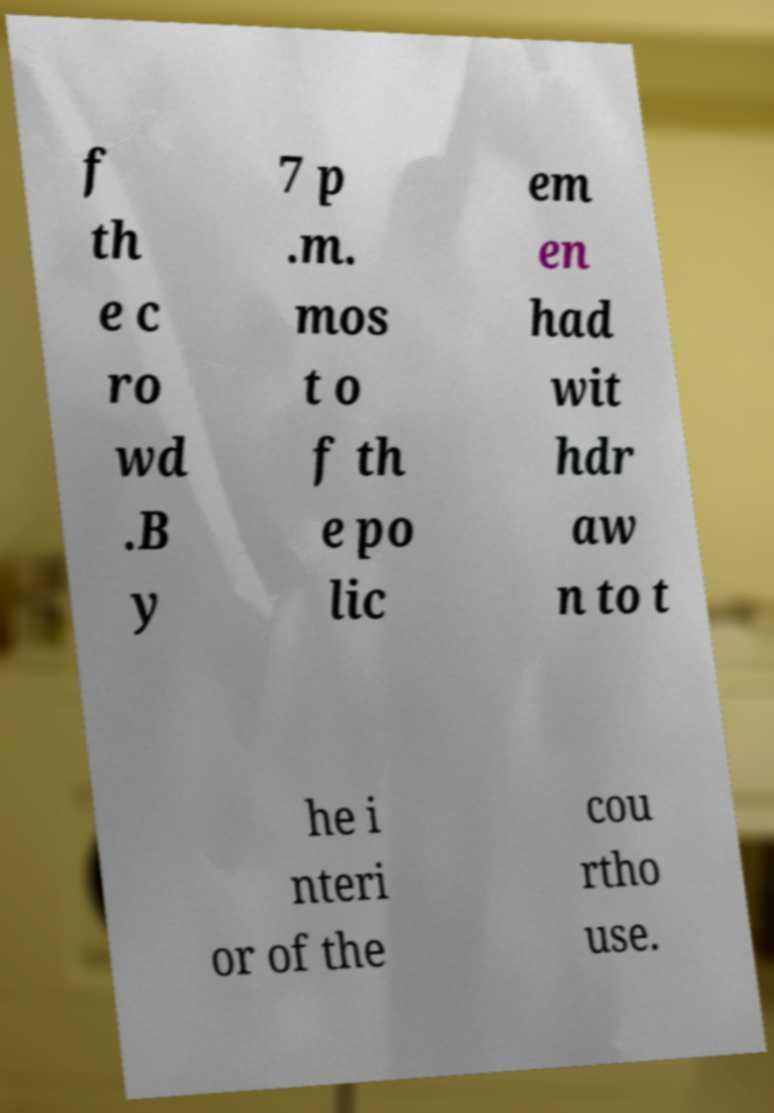Please identify and transcribe the text found in this image. f th e c ro wd .B y 7 p .m. mos t o f th e po lic em en had wit hdr aw n to t he i nteri or of the cou rtho use. 